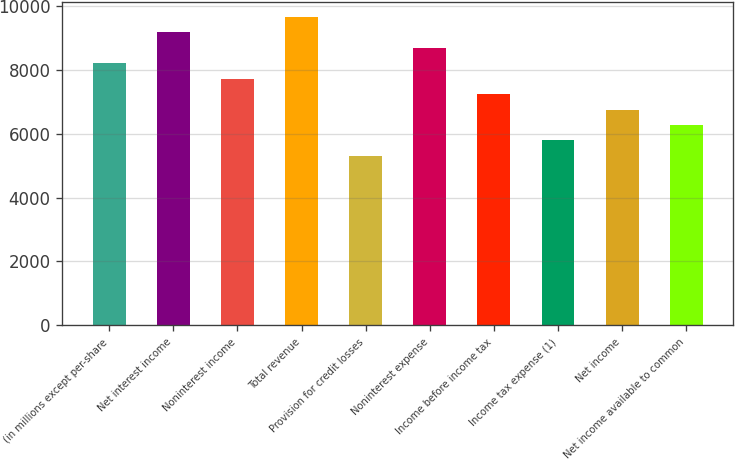<chart> <loc_0><loc_0><loc_500><loc_500><bar_chart><fcel>(in millions except per-share<fcel>Net interest income<fcel>Noninterest income<fcel>Total revenue<fcel>Provision for credit losses<fcel>Noninterest expense<fcel>Income before income tax<fcel>Income tax expense (1)<fcel>Net income<fcel>Net income available to common<nl><fcel>8200.52<fcel>9165.24<fcel>7718.16<fcel>9647.6<fcel>5306.36<fcel>8682.88<fcel>7235.8<fcel>5788.72<fcel>6753.44<fcel>6271.08<nl></chart> 